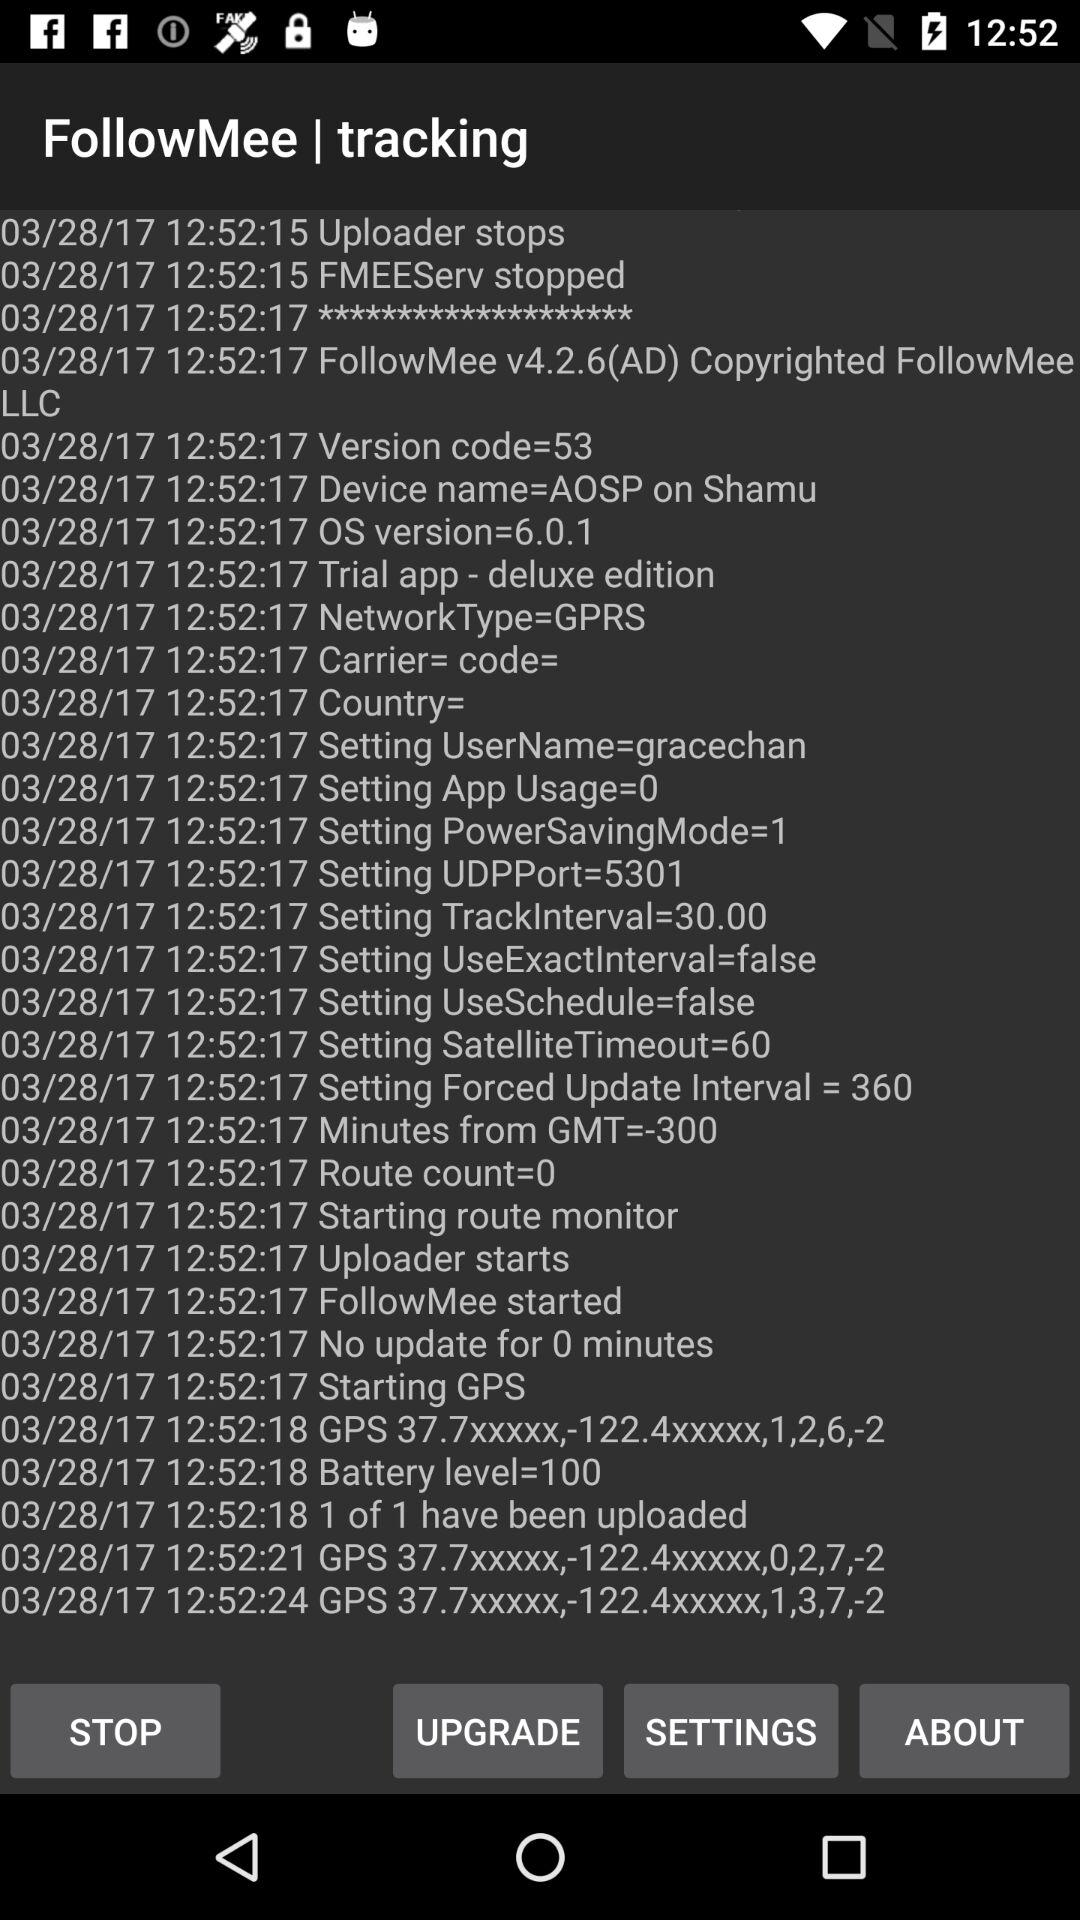What's the forced update interval? The forced update interval is 360. 